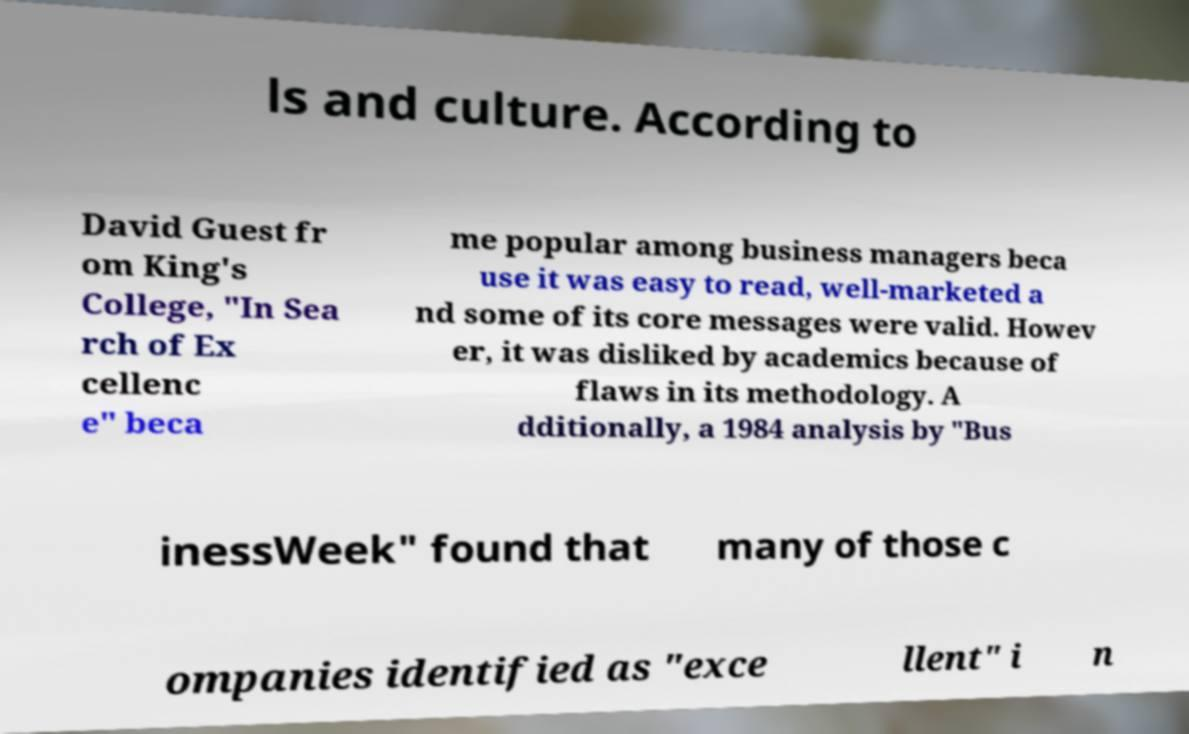Could you extract and type out the text from this image? ls and culture. According to David Guest fr om King's College, "In Sea rch of Ex cellenc e" beca me popular among business managers beca use it was easy to read, well-marketed a nd some of its core messages were valid. Howev er, it was disliked by academics because of flaws in its methodology. A dditionally, a 1984 analysis by "Bus inessWeek" found that many of those c ompanies identified as "exce llent" i n 